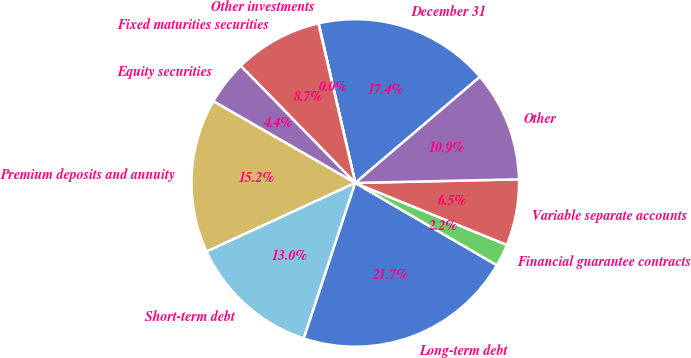Convert chart to OTSL. <chart><loc_0><loc_0><loc_500><loc_500><pie_chart><fcel>December 31<fcel>Other investments<fcel>Fixed maturities securities<fcel>Equity securities<fcel>Premium deposits and annuity<fcel>Short-term debt<fcel>Long-term debt<fcel>Financial guarantee contracts<fcel>Variable separate accounts<fcel>Other<nl><fcel>17.37%<fcel>0.03%<fcel>8.7%<fcel>4.36%<fcel>15.2%<fcel>13.03%<fcel>21.71%<fcel>2.2%<fcel>6.53%<fcel>10.87%<nl></chart> 